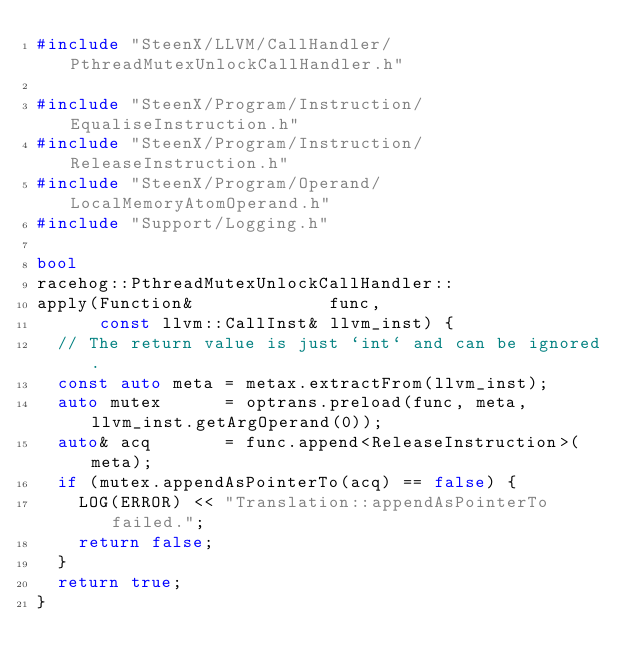Convert code to text. <code><loc_0><loc_0><loc_500><loc_500><_C++_>#include "SteenX/LLVM/CallHandler/PthreadMutexUnlockCallHandler.h"

#include "SteenX/Program/Instruction/EqualiseInstruction.h"
#include "SteenX/Program/Instruction/ReleaseInstruction.h"
#include "SteenX/Program/Operand/LocalMemoryAtomOperand.h"
#include "Support/Logging.h"

bool
racehog::PthreadMutexUnlockCallHandler::
apply(Function&             func,
      const llvm::CallInst& llvm_inst) {
  // The return value is just `int` and can be ignored.
  const auto meta = metax.extractFrom(llvm_inst);
  auto mutex      = optrans.preload(func, meta, llvm_inst.getArgOperand(0));
  auto& acq       = func.append<ReleaseInstruction>(meta);
  if (mutex.appendAsPointerTo(acq) == false) {
    LOG(ERROR) << "Translation::appendAsPointerTo failed.";
    return false;
  }
  return true;
}
</code> 